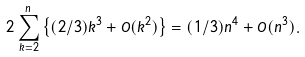<formula> <loc_0><loc_0><loc_500><loc_500>2 \sum _ { k = 2 } ^ { n } \left \{ ( 2 / 3 ) k ^ { 3 } + O ( k ^ { 2 } ) \right \} = ( 1 / 3 ) n ^ { 4 } + O ( n ^ { 3 } ) .</formula> 